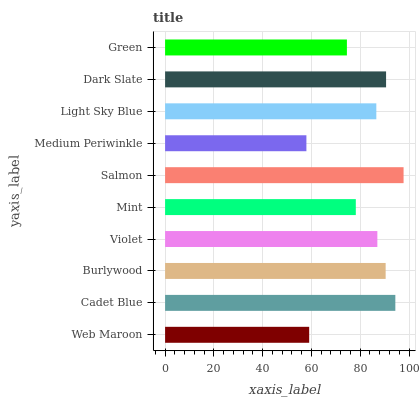Is Medium Periwinkle the minimum?
Answer yes or no. Yes. Is Salmon the maximum?
Answer yes or no. Yes. Is Cadet Blue the minimum?
Answer yes or no. No. Is Cadet Blue the maximum?
Answer yes or no. No. Is Cadet Blue greater than Web Maroon?
Answer yes or no. Yes. Is Web Maroon less than Cadet Blue?
Answer yes or no. Yes. Is Web Maroon greater than Cadet Blue?
Answer yes or no. No. Is Cadet Blue less than Web Maroon?
Answer yes or no. No. Is Violet the high median?
Answer yes or no. Yes. Is Light Sky Blue the low median?
Answer yes or no. Yes. Is Salmon the high median?
Answer yes or no. No. Is Mint the low median?
Answer yes or no. No. 